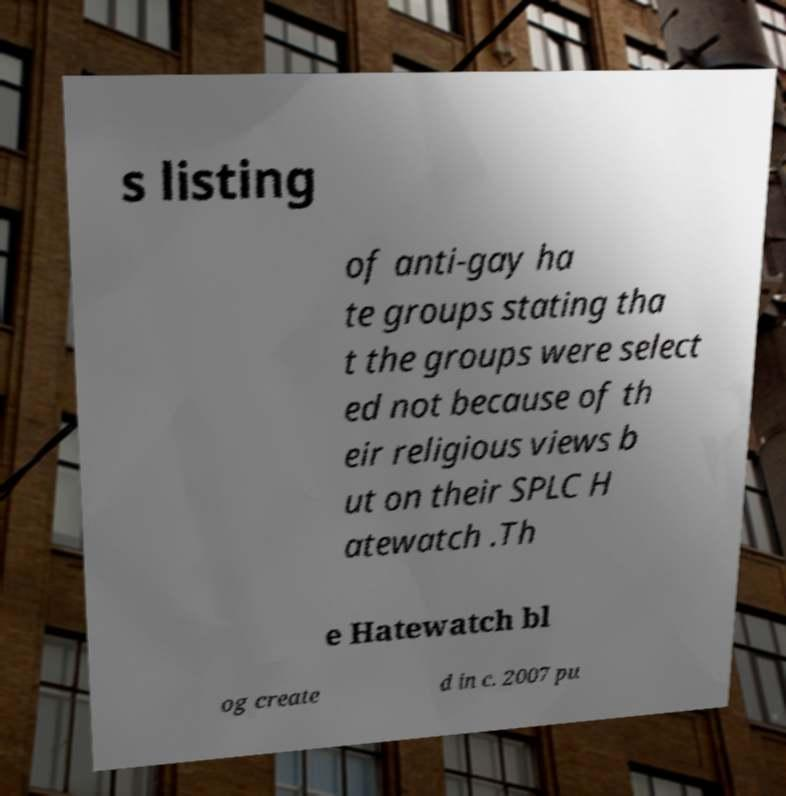What messages or text are displayed in this image? I need them in a readable, typed format. s listing of anti-gay ha te groups stating tha t the groups were select ed not because of th eir religious views b ut on their SPLC H atewatch .Th e Hatewatch bl og create d in c. 2007 pu 